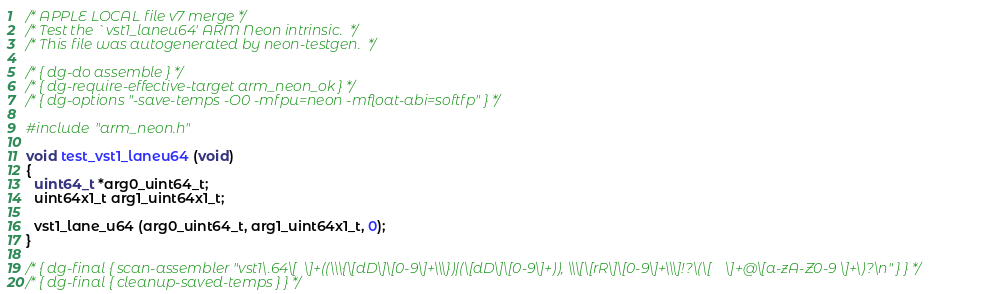<code> <loc_0><loc_0><loc_500><loc_500><_C_>/* APPLE LOCAL file v7 merge */
/* Test the `vst1_laneu64' ARM Neon intrinsic.  */
/* This file was autogenerated by neon-testgen.  */

/* { dg-do assemble } */
/* { dg-require-effective-target arm_neon_ok } */
/* { dg-options "-save-temps -O0 -mfpu=neon -mfloat-abi=softfp" } */

#include "arm_neon.h"

void test_vst1_laneu64 (void)
{
  uint64_t *arg0_uint64_t;
  uint64x1_t arg1_uint64x1_t;

  vst1_lane_u64 (arg0_uint64_t, arg1_uint64x1_t, 0);
}

/* { dg-final { scan-assembler "vst1\.64\[ 	\]+((\\\{\[dD\]\[0-9\]+\\\})|(\[dD\]\[0-9\]+)), \\\[\[rR\]\[0-9\]+\\\]!?\(\[ 	\]+@\[a-zA-Z0-9 \]+\)?\n" } } */
/* { dg-final { cleanup-saved-temps } } */
</code> 